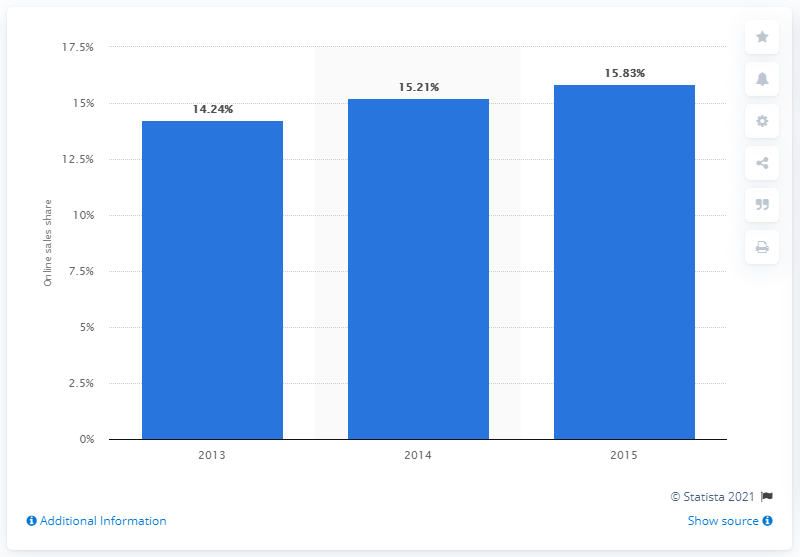Mention a couple of crucial points in this snapshot. In 2015, online sales of The Gap Inc. accounted for 15.83 percent of the company's total sales. 